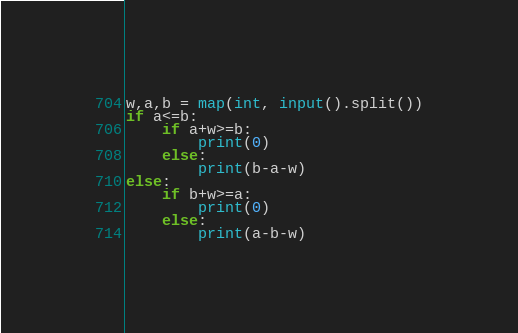Convert code to text. <code><loc_0><loc_0><loc_500><loc_500><_Python_>w,a,b = map(int, input().split())
if a<=b:
    if a+w>=b:
        print(0)
    else:
        print(b-a-w)
else:
    if b+w>=a:
        print(0)
    else:
        print(a-b-w)    
</code> 